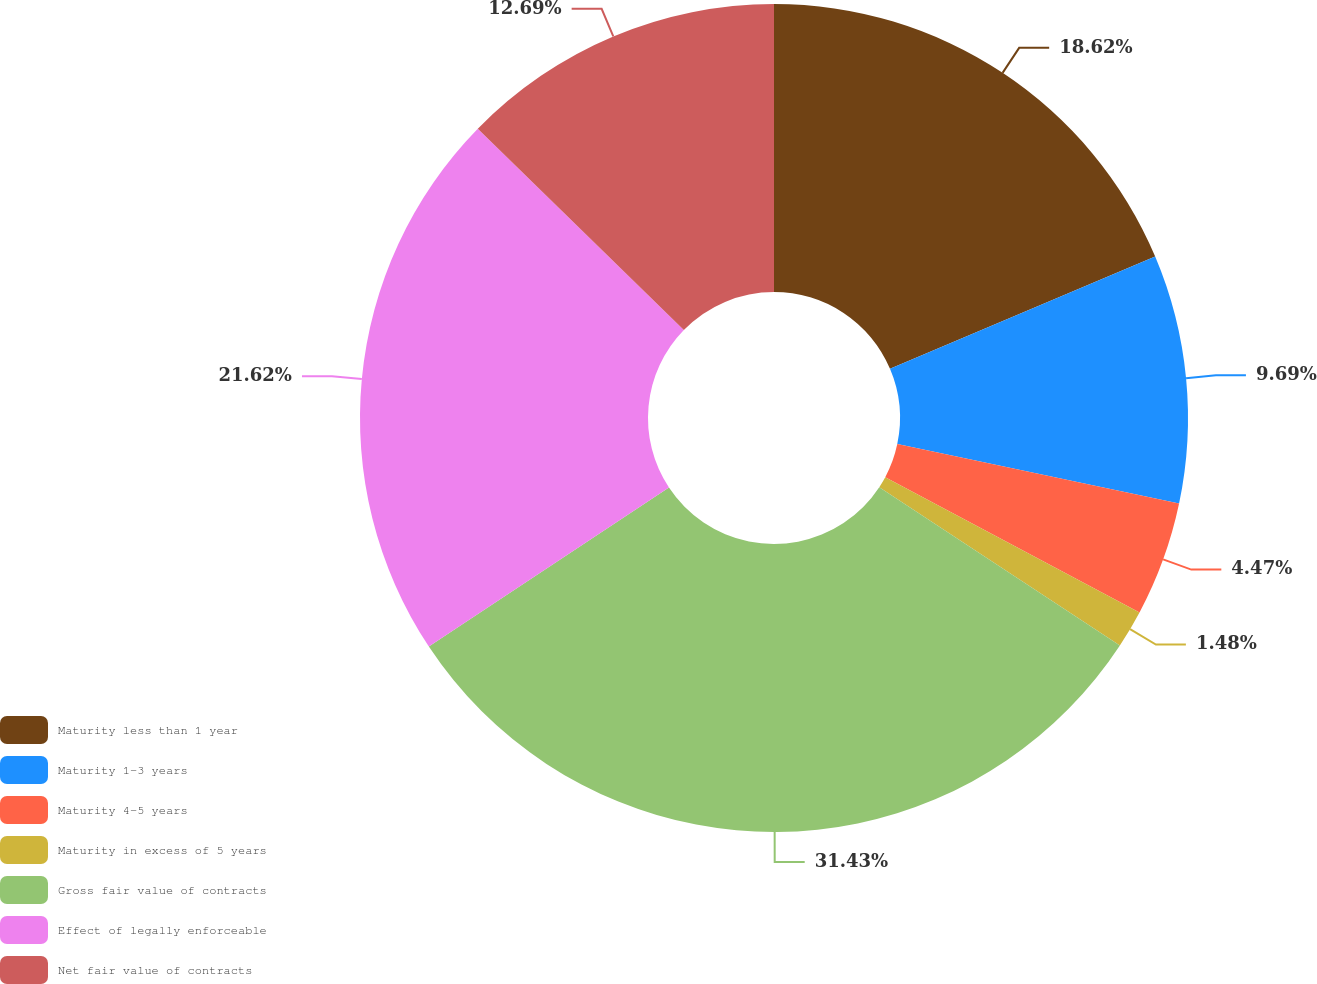<chart> <loc_0><loc_0><loc_500><loc_500><pie_chart><fcel>Maturity less than 1 year<fcel>Maturity 1-3 years<fcel>Maturity 4-5 years<fcel>Maturity in excess of 5 years<fcel>Gross fair value of contracts<fcel>Effect of legally enforceable<fcel>Net fair value of contracts<nl><fcel>18.62%<fcel>9.69%<fcel>4.47%<fcel>1.48%<fcel>31.43%<fcel>21.62%<fcel>12.69%<nl></chart> 